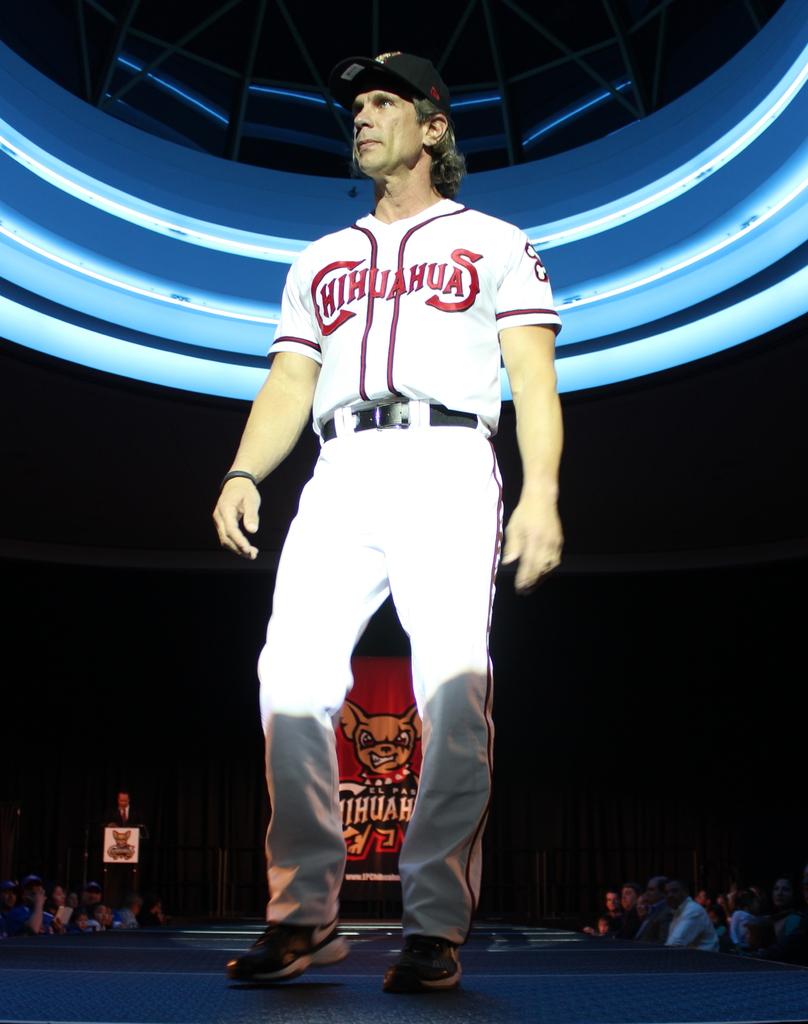What is the team name?
Your answer should be compact. Chihuahuas. 